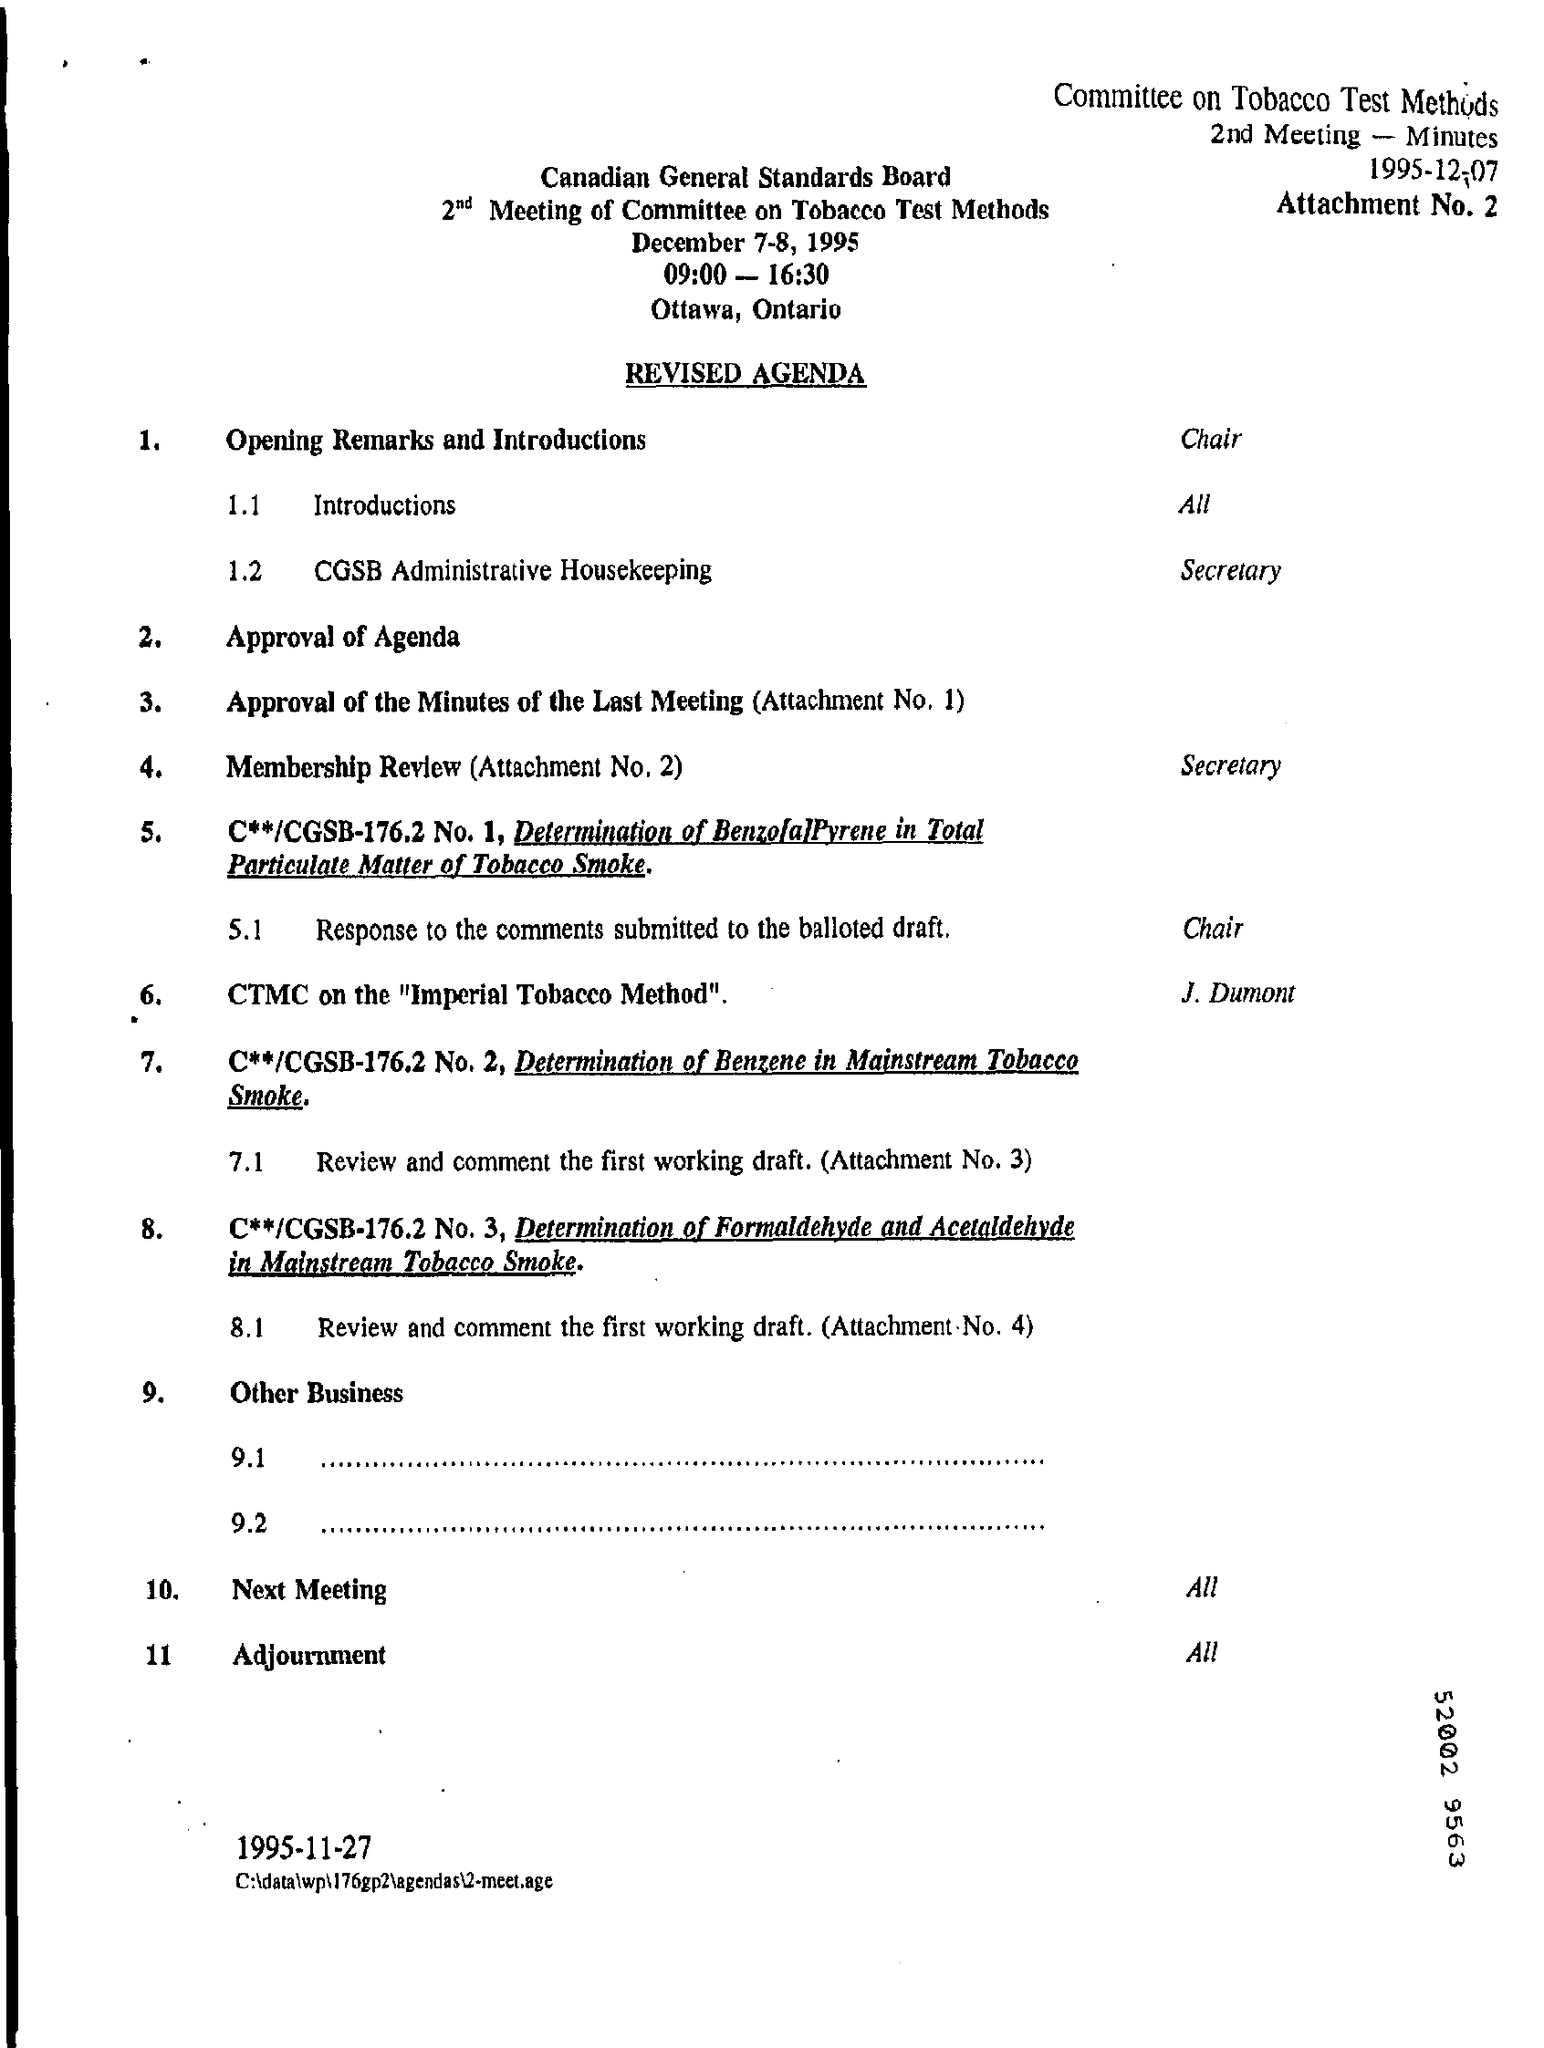When is the meeting held?
Your answer should be compact. December 7-8, 1995. Where is the Meeting held?
Provide a short and direct response. Ottawa, Ontario. 